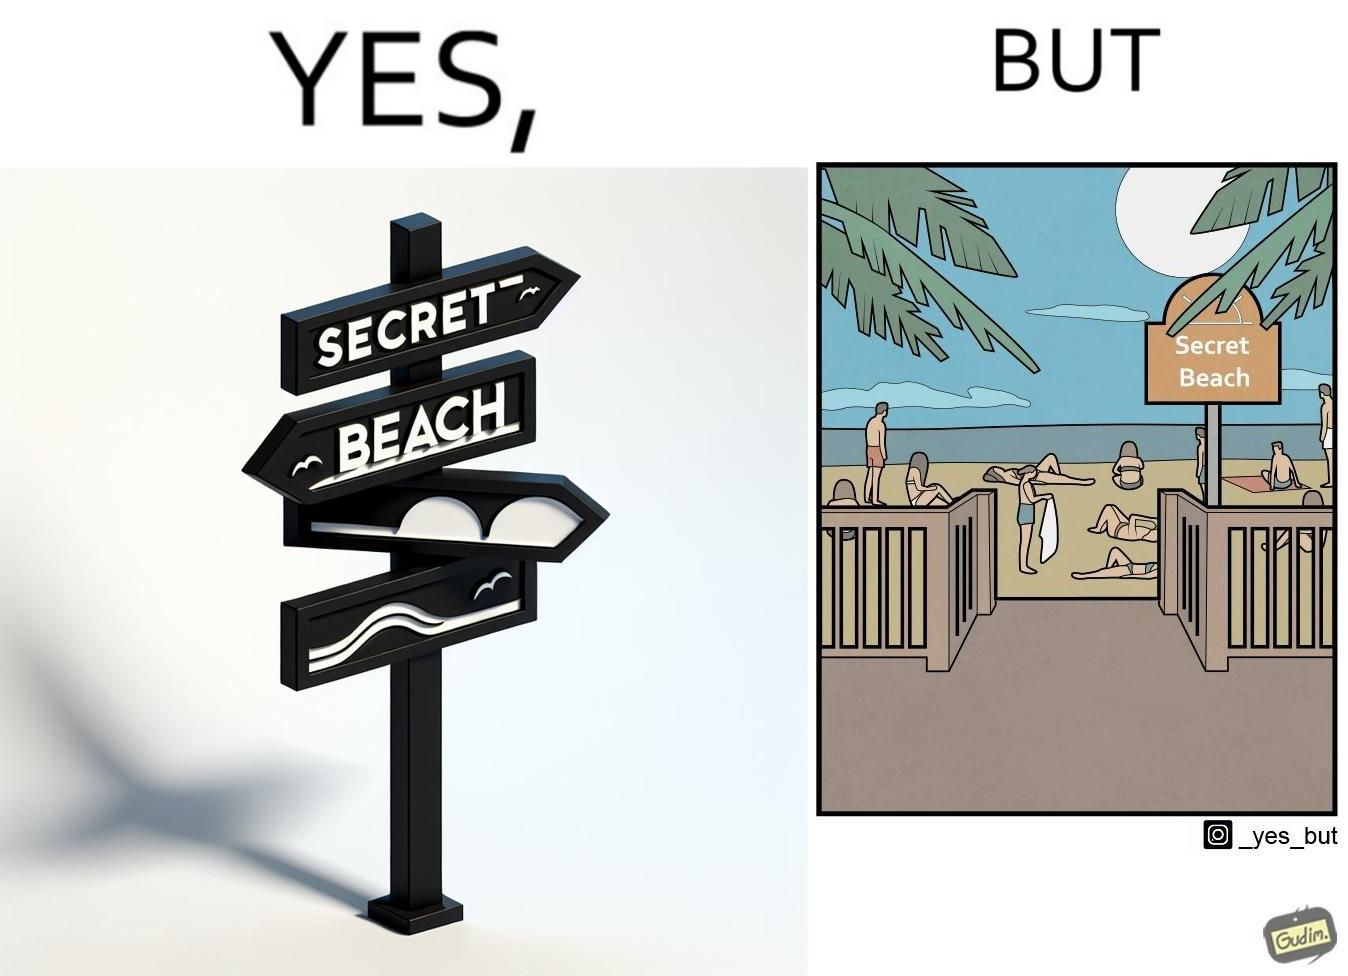Describe what you see in this image. The image is ironical, as people can be seen in the beach, and is clearly not a secret, while the board at the entrance has "Secret Beach" written on it. 